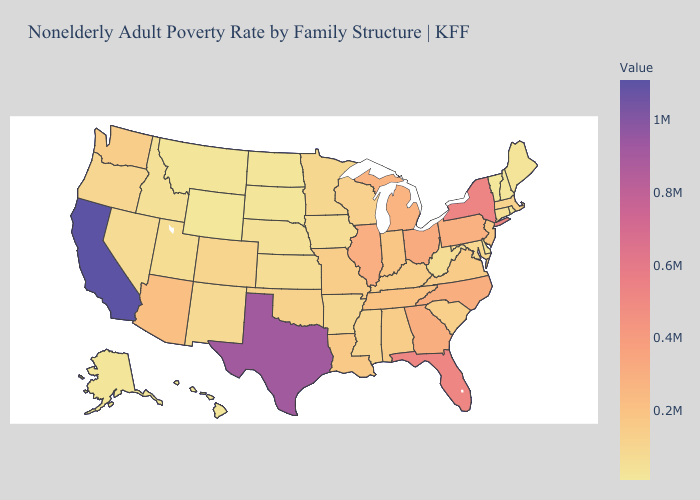Among the states that border Nebraska , does Missouri have the highest value?
Answer briefly. Yes. Does Washington have a lower value than North Carolina?
Answer briefly. Yes. Does Vermont have the lowest value in the Northeast?
Concise answer only. Yes. Which states have the highest value in the USA?
Keep it brief. California. Does North Dakota have the lowest value in the MidWest?
Be succinct. Yes. 